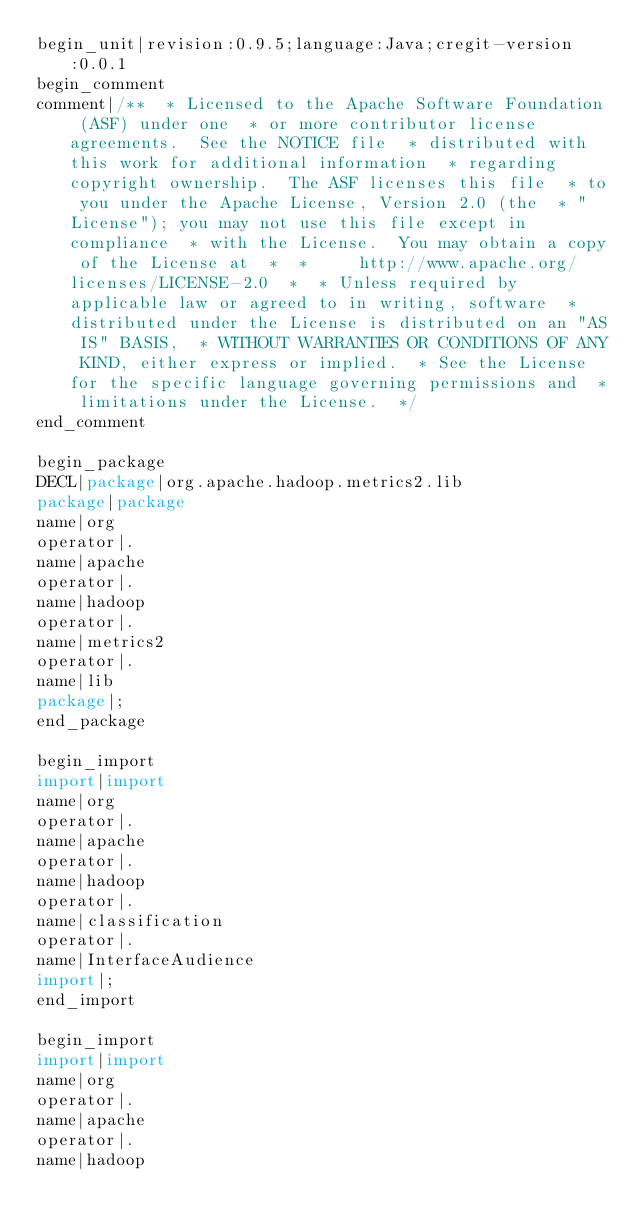Convert code to text. <code><loc_0><loc_0><loc_500><loc_500><_Java_>begin_unit|revision:0.9.5;language:Java;cregit-version:0.0.1
begin_comment
comment|/**  * Licensed to the Apache Software Foundation (ASF) under one  * or more contributor license agreements.  See the NOTICE file  * distributed with this work for additional information  * regarding copyright ownership.  The ASF licenses this file  * to you under the Apache License, Version 2.0 (the  * "License"); you may not use this file except in compliance  * with the License.  You may obtain a copy of the License at  *  *     http://www.apache.org/licenses/LICENSE-2.0  *  * Unless required by applicable law or agreed to in writing, software  * distributed under the License is distributed on an "AS IS" BASIS,  * WITHOUT WARRANTIES OR CONDITIONS OF ANY KIND, either express or implied.  * See the License for the specific language governing permissions and  * limitations under the License.  */
end_comment

begin_package
DECL|package|org.apache.hadoop.metrics2.lib
package|package
name|org
operator|.
name|apache
operator|.
name|hadoop
operator|.
name|metrics2
operator|.
name|lib
package|;
end_package

begin_import
import|import
name|org
operator|.
name|apache
operator|.
name|hadoop
operator|.
name|classification
operator|.
name|InterfaceAudience
import|;
end_import

begin_import
import|import
name|org
operator|.
name|apache
operator|.
name|hadoop</code> 